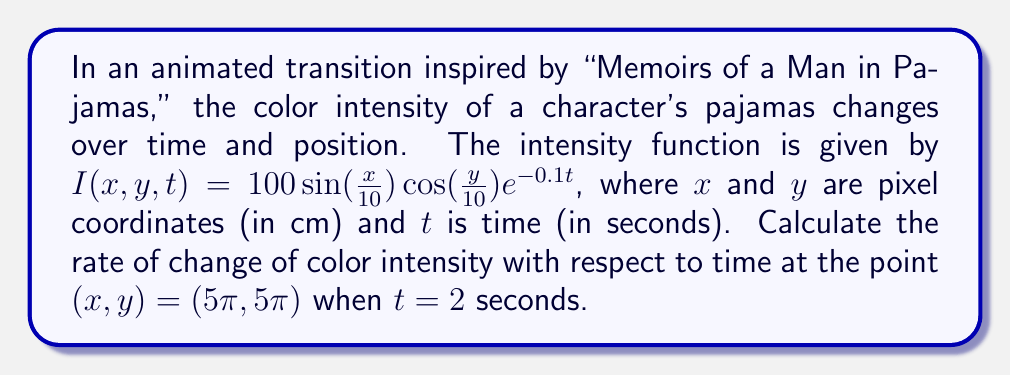What is the answer to this math problem? To find the rate of change of color intensity with respect to time, we need to calculate the partial derivative of $I$ with respect to $t$ and evaluate it at the given point.

Step 1: Calculate $\frac{\partial I}{\partial t}$
$$\frac{\partial I}{\partial t} = 100 \sin(\frac{x}{10}) \cos(\frac{y}{10}) \cdot \frac{\partial}{\partial t}(e^{-0.1t}) = -10 \sin(\frac{x}{10}) \cos(\frac{y}{10}) e^{-0.1t}$$

Step 2: Evaluate $\frac{\partial I}{\partial t}$ at $(x, y, t) = (5\pi, 5\pi, 2)$
$$\begin{aligned}
\frac{\partial I}{\partial t}(5\pi, 5\pi, 2) &= -10 \sin(\frac{5\pi}{10}) \cos(\frac{5\pi}{10}) e^{-0.1(2)} \\
&= -10 \sin(\frac{\pi}{2}) \cos(\frac{\pi}{2}) e^{-0.2} \\
&= -10 \cdot 1 \cdot 0 \cdot e^{-0.2} \\
&= 0
\end{aligned}$$

Therefore, the rate of change of color intensity with respect to time at the given point is 0.
Answer: $0$ intensity units per second 